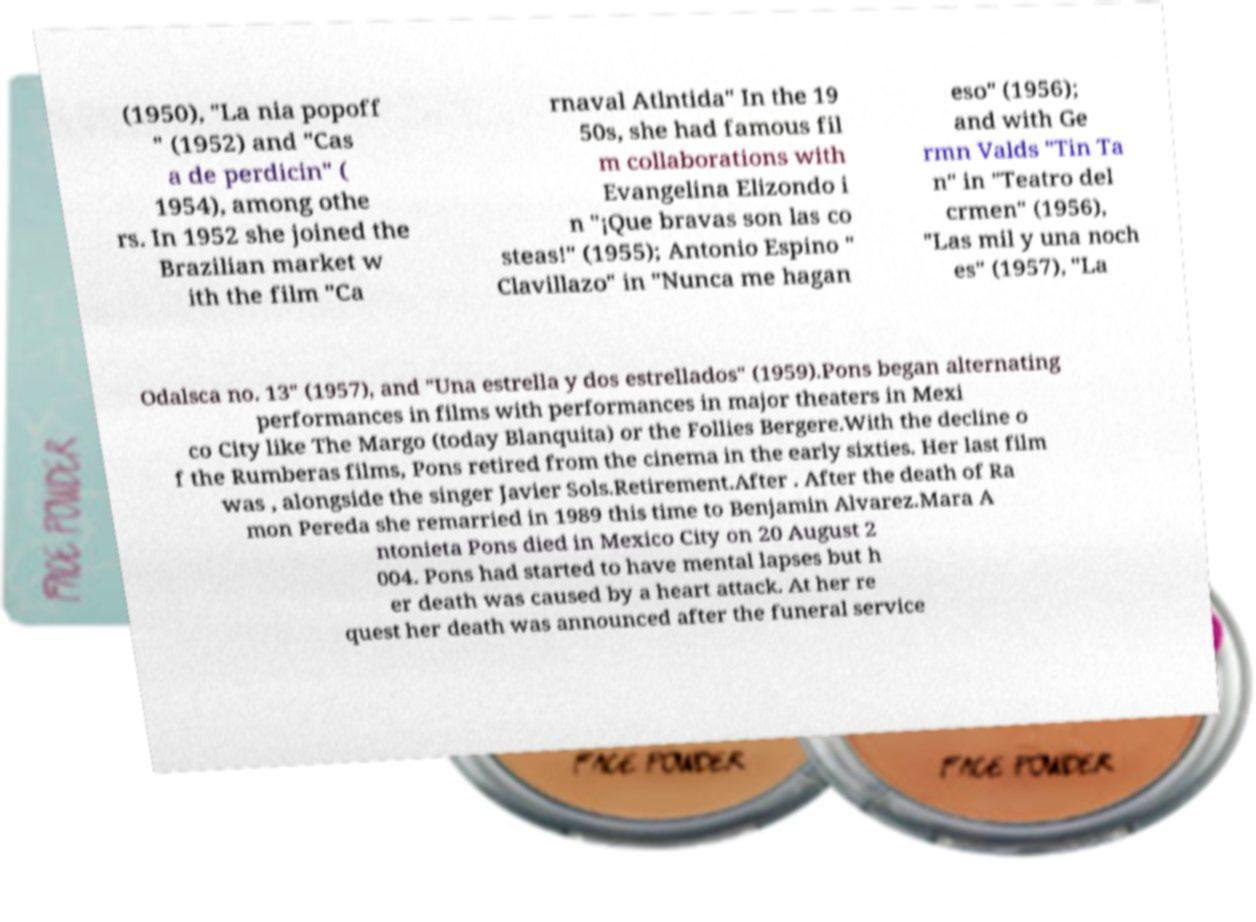There's text embedded in this image that I need extracted. Can you transcribe it verbatim? (1950), "La nia popoff " (1952) and "Cas a de perdicin" ( 1954), among othe rs. In 1952 she joined the Brazilian market w ith the film "Ca rnaval Atlntida" In the 19 50s, she had famous fil m collaborations with Evangelina Elizondo i n "¡Que bravas son las co steas!" (1955); Antonio Espino " Clavillazo" in "Nunca me hagan eso" (1956); and with Ge rmn Valds "Tin Ta n" in "Teatro del crmen" (1956), "Las mil y una noch es" (1957), "La Odalsca no. 13" (1957), and "Una estrella y dos estrellados" (1959).Pons began alternating performances in films with performances in major theaters in Mexi co City like The Margo (today Blanquita) or the Follies Bergere.With the decline o f the Rumberas films, Pons retired from the cinema in the early sixties. Her last film was , alongside the singer Javier Sols.Retirement.After . After the death of Ra mon Pereda she remarried in 1989 this time to Benjamin Alvarez.Mara A ntonieta Pons died in Mexico City on 20 August 2 004. Pons had started to have mental lapses but h er death was caused by a heart attack. At her re quest her death was announced after the funeral service 